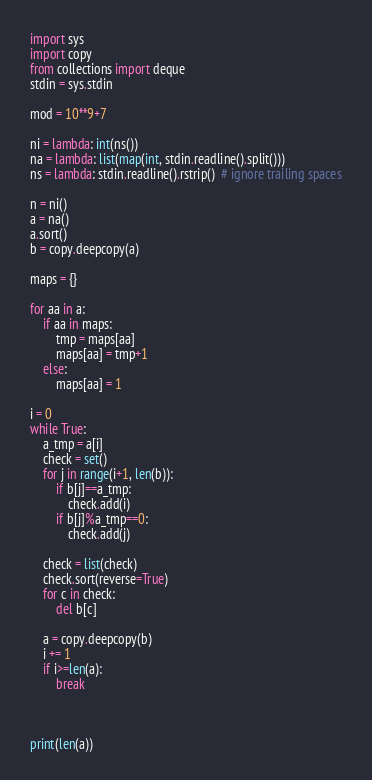<code> <loc_0><loc_0><loc_500><loc_500><_Python_>import sys
import copy
from collections import deque
stdin = sys.stdin

mod = 10**9+7

ni = lambda: int(ns())
na = lambda: list(map(int, stdin.readline().split()))
ns = lambda: stdin.readline().rstrip()  # ignore trailing spaces

n = ni()
a = na()
a.sort()
b = copy.deepcopy(a)

maps = {}

for aa in a:
    if aa in maps:
        tmp = maps[aa]
        maps[aa] = tmp+1
    else:
        maps[aa] = 1

i = 0
while True:
    a_tmp = a[i]
    check = set()
    for j in range(i+1, len(b)):
        if b[j]==a_tmp:
            check.add(i)
        if b[j]%a_tmp==0:
            check.add(j)

    check = list(check)
    check.sort(reverse=True)
    for c in check:
        del b[c]
    
    a = copy.deepcopy(b)
    i += 1
    if i>=len(a):
        break



print(len(a))



</code> 